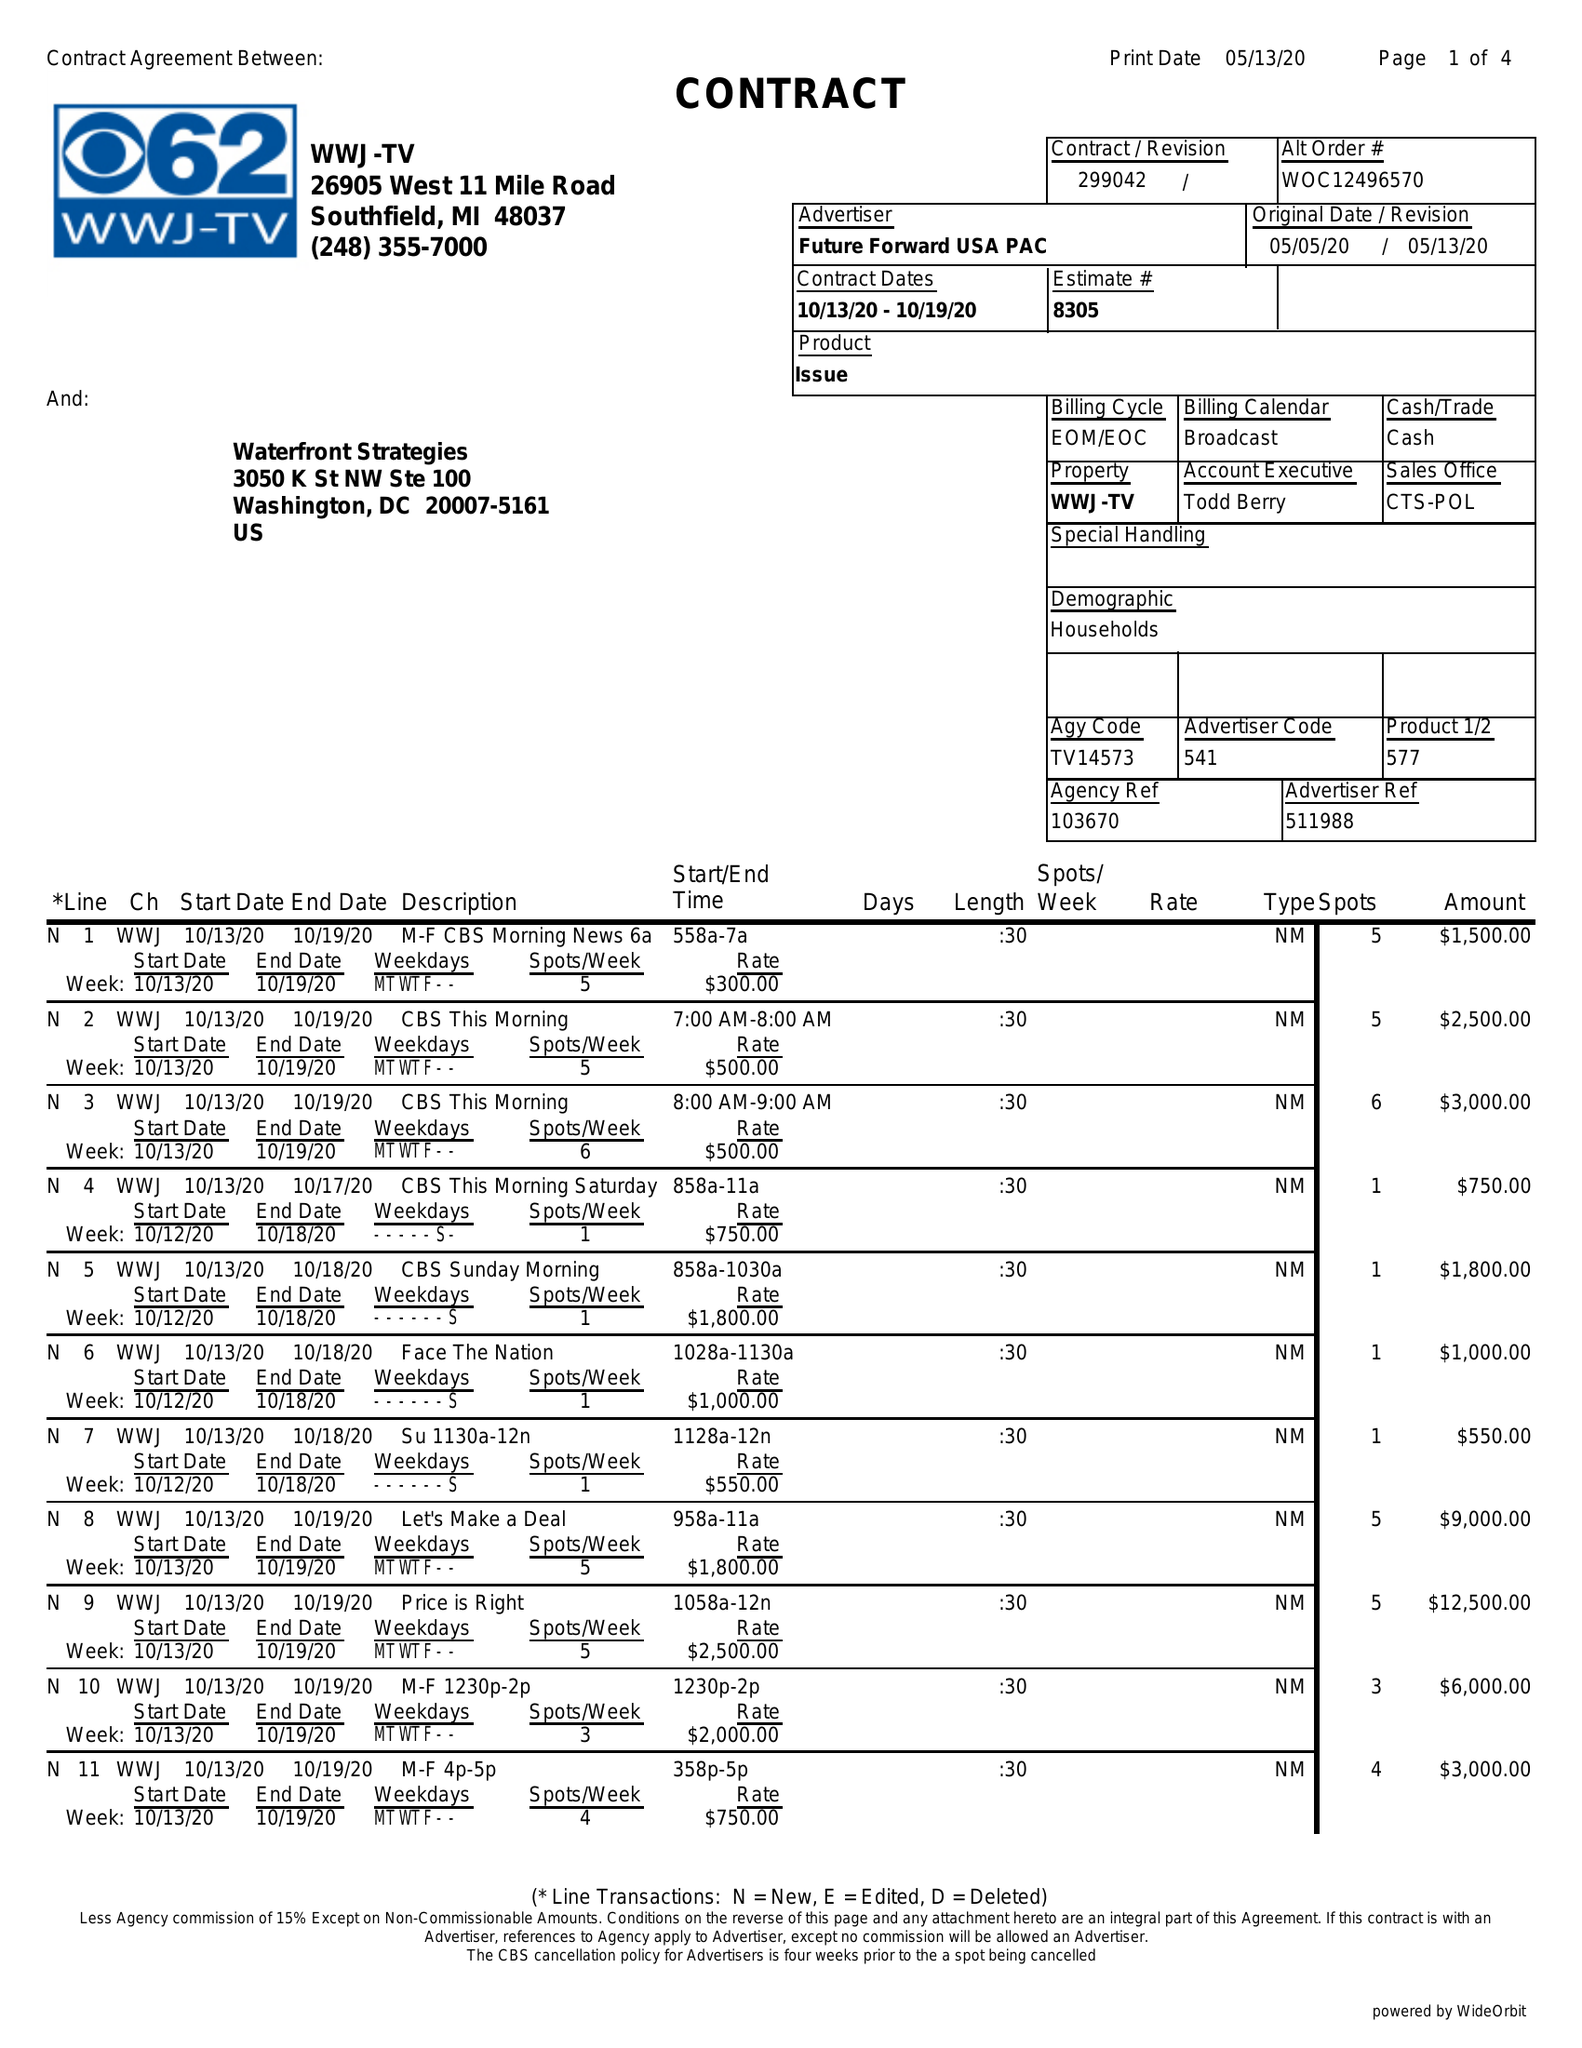What is the value for the flight_to?
Answer the question using a single word or phrase. 10/19/20 